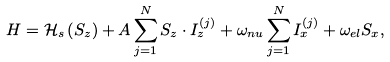Convert formula to latex. <formula><loc_0><loc_0><loc_500><loc_500>H = \mathcal { H } _ { s } \left ( S _ { z } \right ) + A \sum _ { j = 1 } ^ { N } S _ { z } \cdot I _ { z } ^ { \left ( j \right ) } + \omega _ { n u } \sum _ { j = 1 } ^ { N } I _ { x } ^ { \left ( j \right ) } + \omega _ { e l } S _ { x } ,</formula> 